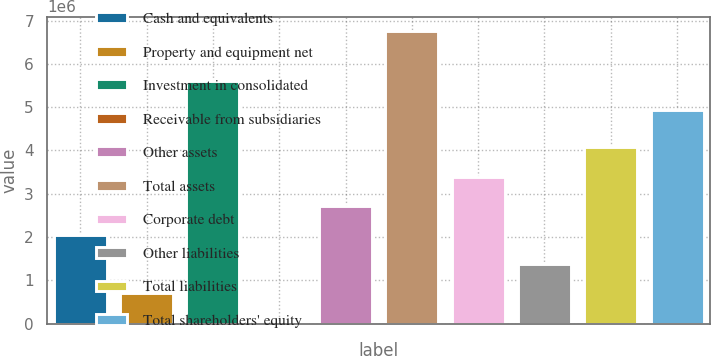<chart> <loc_0><loc_0><loc_500><loc_500><bar_chart><fcel>Cash and equivalents<fcel>Property and equipment net<fcel>Investment in consolidated<fcel>Receivable from subsidiaries<fcel>Other assets<fcel>Total assets<fcel>Corporate debt<fcel>Other liabilities<fcel>Total liabilities<fcel>Total shareholders' equity<nl><fcel>2.05451e+06<fcel>712109<fcel>5.59915e+06<fcel>40906<fcel>2.72572e+06<fcel>6.75293e+06<fcel>3.39692e+06<fcel>1.38331e+06<fcel>4.06812e+06<fcel>4.92795e+06<nl></chart> 